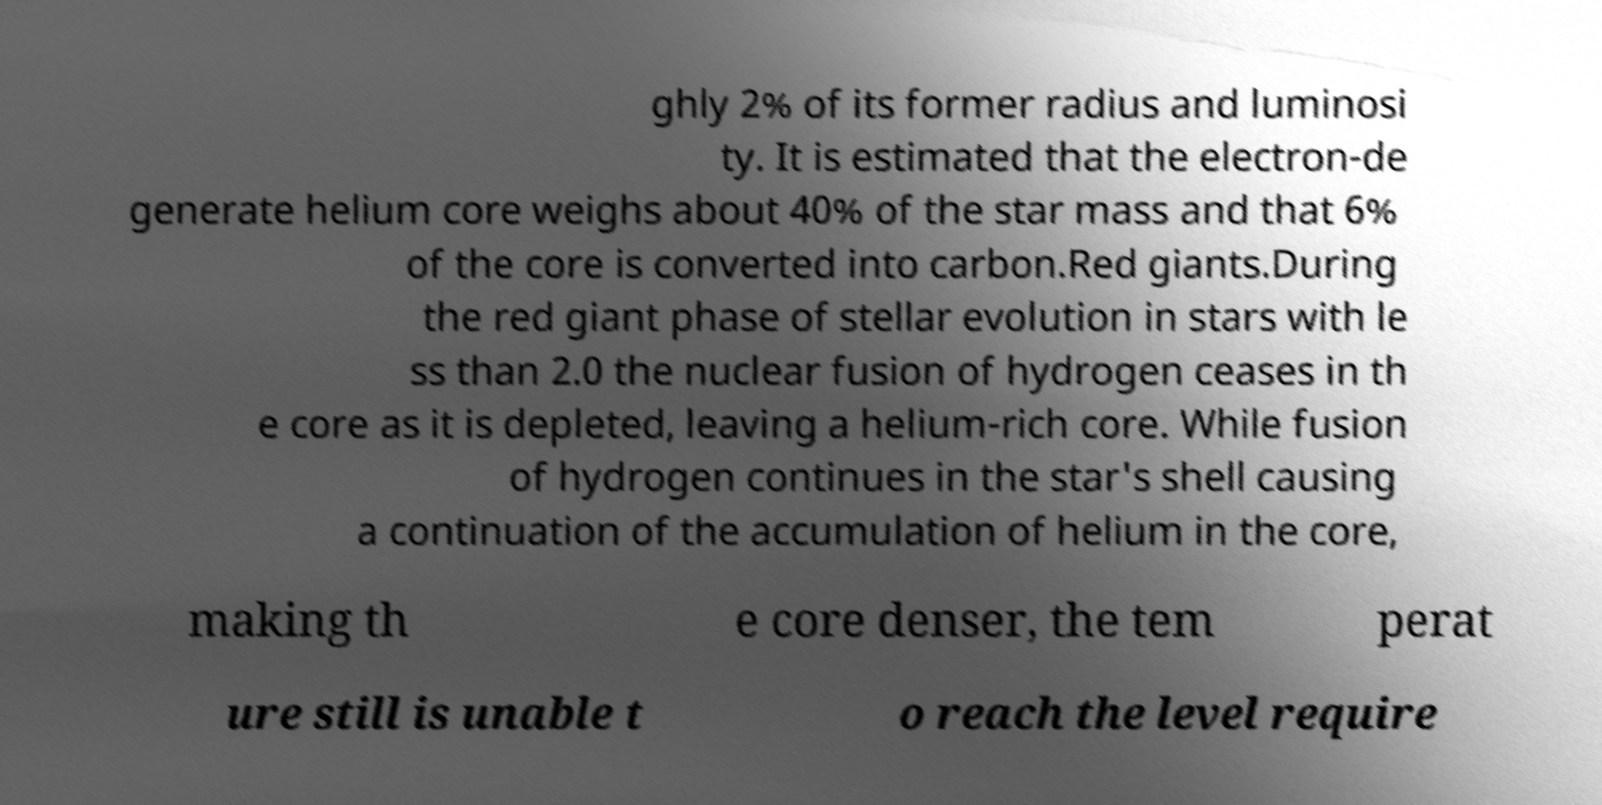Please read and relay the text visible in this image. What does it say? ghly 2% of its former radius and luminosi ty. It is estimated that the electron-de generate helium core weighs about 40% of the star mass and that 6% of the core is converted into carbon.Red giants.During the red giant phase of stellar evolution in stars with le ss than 2.0 the nuclear fusion of hydrogen ceases in th e core as it is depleted, leaving a helium-rich core. While fusion of hydrogen continues in the star's shell causing a continuation of the accumulation of helium in the core, making th e core denser, the tem perat ure still is unable t o reach the level require 